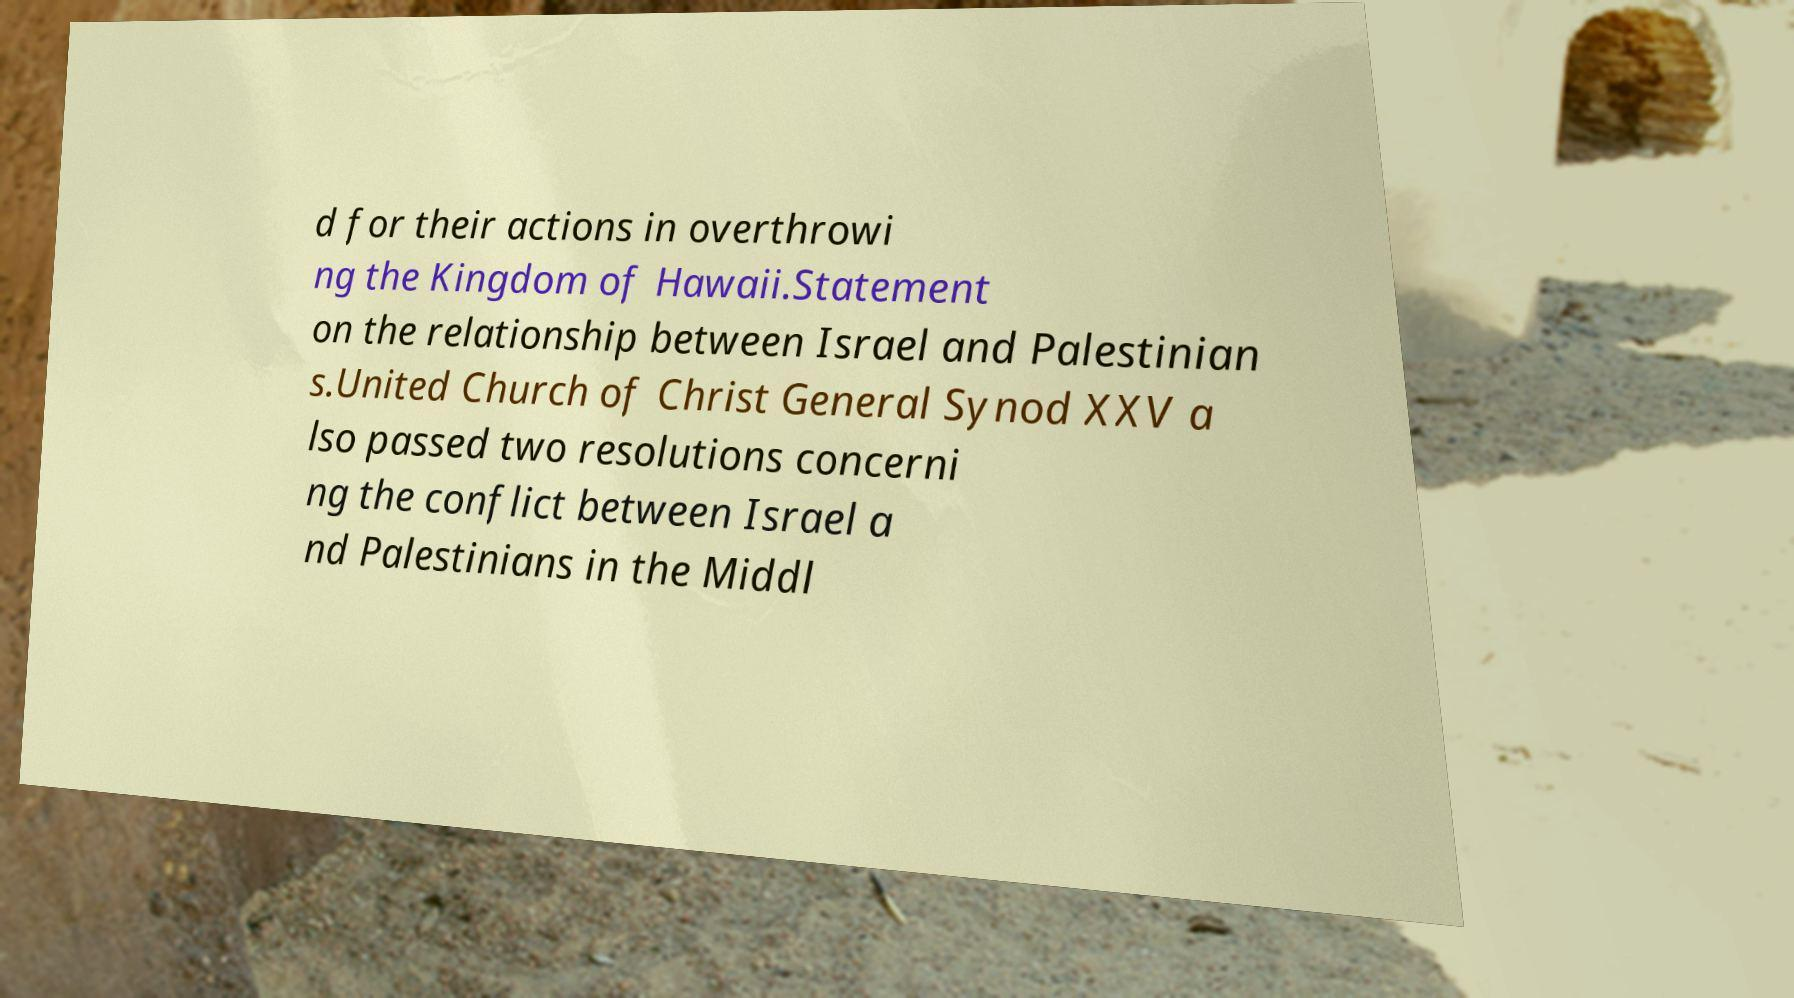For documentation purposes, I need the text within this image transcribed. Could you provide that? d for their actions in overthrowi ng the Kingdom of Hawaii.Statement on the relationship between Israel and Palestinian s.United Church of Christ General Synod XXV a lso passed two resolutions concerni ng the conflict between Israel a nd Palestinians in the Middl 